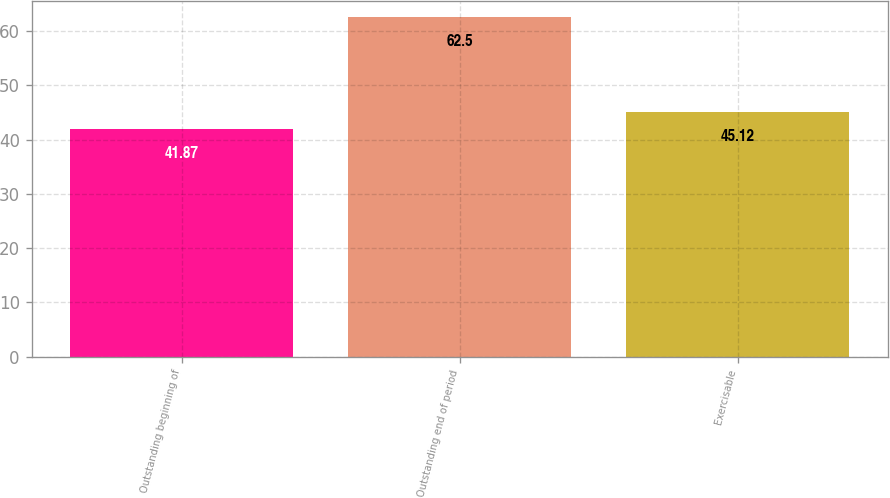Convert chart. <chart><loc_0><loc_0><loc_500><loc_500><bar_chart><fcel>Outstanding beginning of<fcel>Outstanding end of period<fcel>Exercisable<nl><fcel>41.87<fcel>62.5<fcel>45.12<nl></chart> 